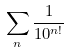<formula> <loc_0><loc_0><loc_500><loc_500>\sum _ { n } \frac { 1 } { 1 0 ^ { n ! } }</formula> 